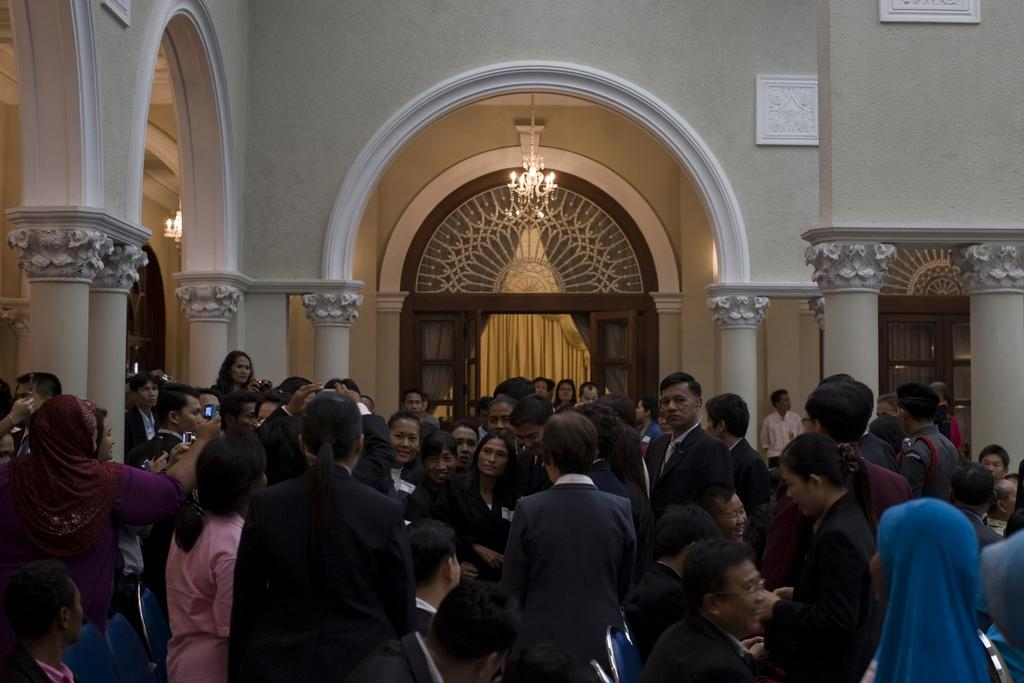Where was the image taken? The image was taken inside a room. What can be seen at the top of the room? There is light at the top of the room. What is in the middle of the room? There is a curtain in the middle of the room. What is happening in the middle of the room? There are people standing in the middle of the room. What type of organization is being held in the cave in the image? There is no cave present in the image, and therefore no organization is being held in a cave. 